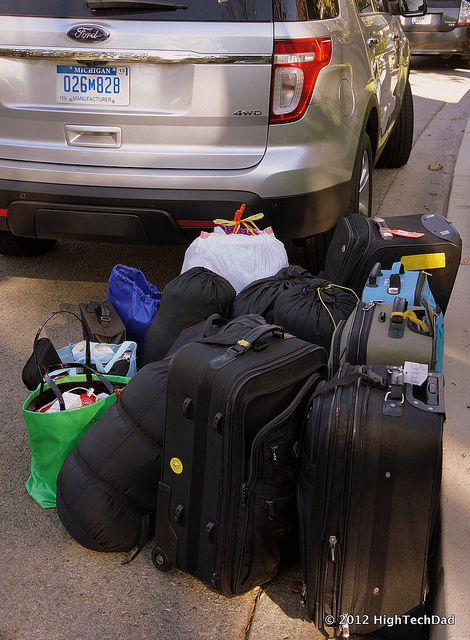<image>Which bag is sky blue? I am not sure which bag is sky blue. It could be the 'right', 'blue one', 'drawstring', or 'second to back'. Which bag is sky blue? I don't know which bag is sky blue. It can be the 'blue one', 'drawstring', 'second to back', 'one near back', or 'next to white bag'. 